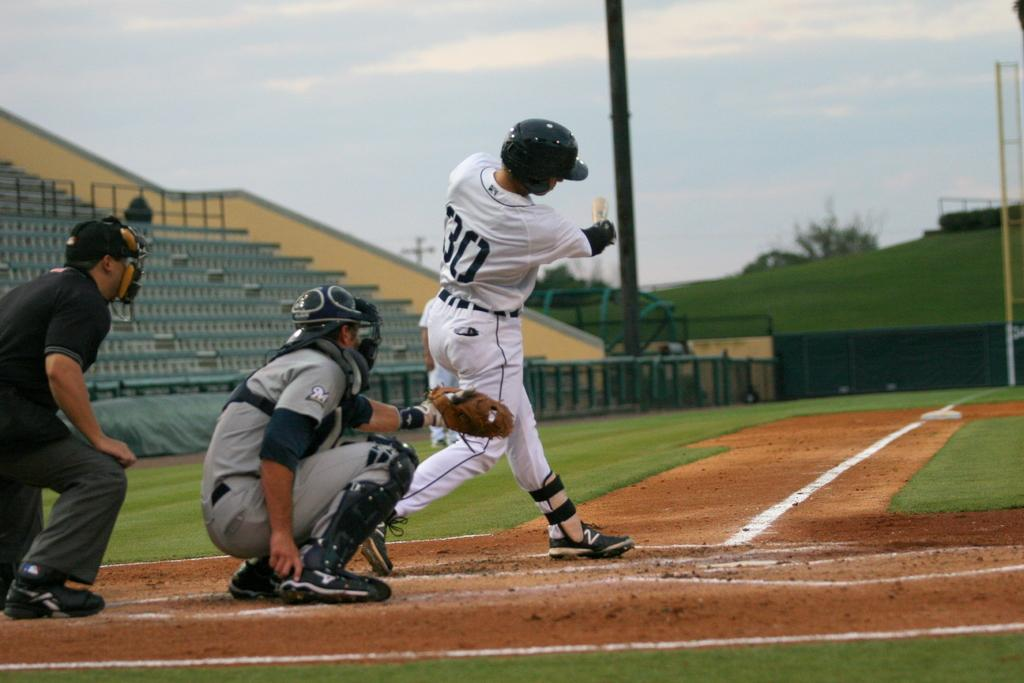<image>
Give a short and clear explanation of the subsequent image. A baseball player with a white and black uniform with the number thirty on his back is about to swing his bat. 